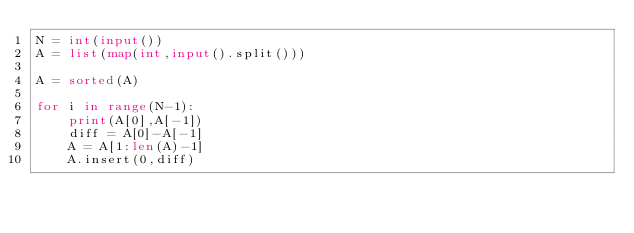Convert code to text. <code><loc_0><loc_0><loc_500><loc_500><_Python_>N = int(input())
A = list(map(int,input().split()))

A = sorted(A)

for i in range(N-1):
    print(A[0],A[-1])
    diff = A[0]-A[-1]
    A = A[1:len(A)-1]
    A.insert(0,diff)</code> 